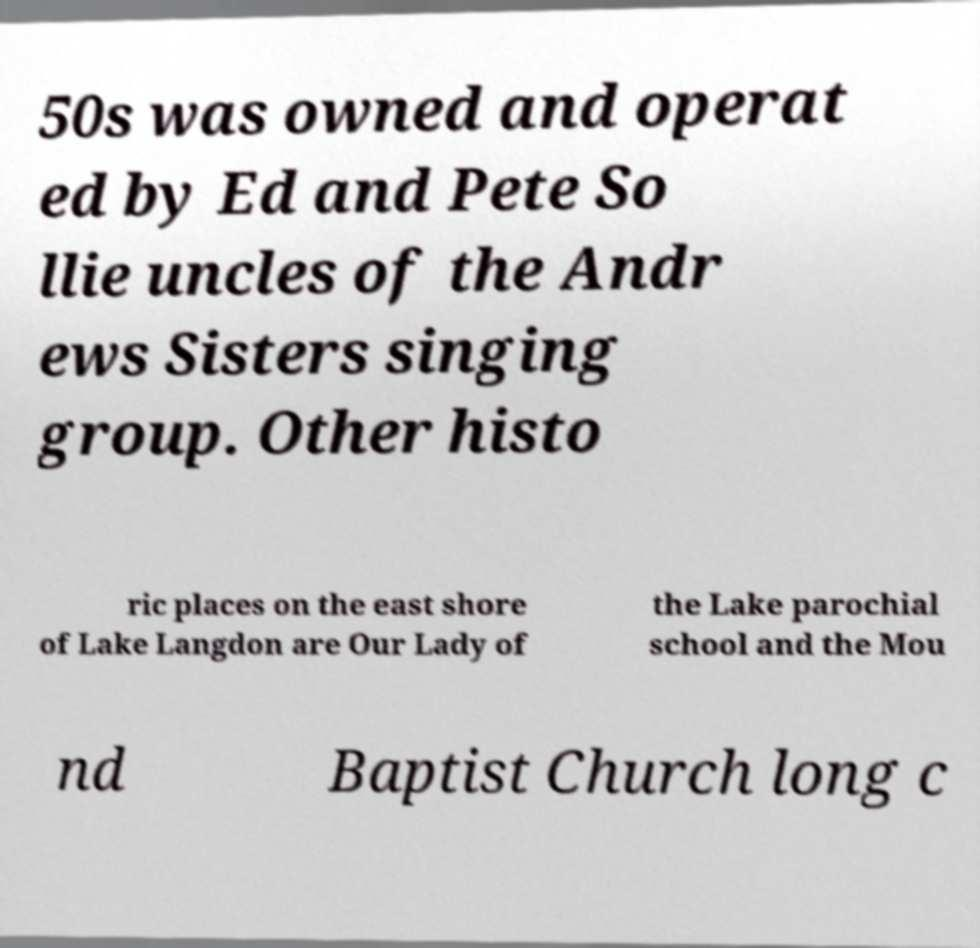Please read and relay the text visible in this image. What does it say? 50s was owned and operat ed by Ed and Pete So llie uncles of the Andr ews Sisters singing group. Other histo ric places on the east shore of Lake Langdon are Our Lady of the Lake parochial school and the Mou nd Baptist Church long c 